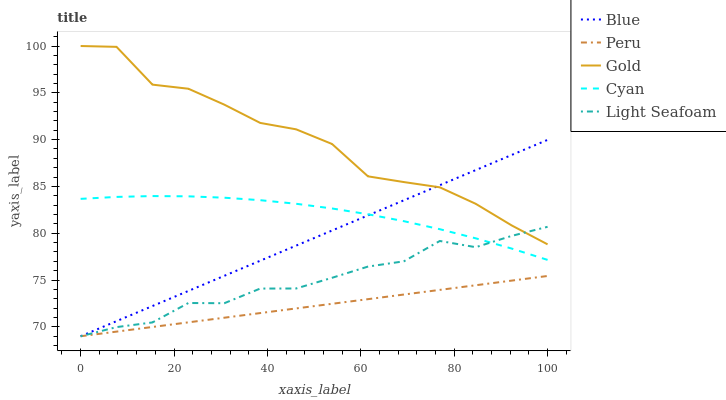Does Peru have the minimum area under the curve?
Answer yes or no. Yes. Does Gold have the maximum area under the curve?
Answer yes or no. Yes. Does Cyan have the minimum area under the curve?
Answer yes or no. No. Does Cyan have the maximum area under the curve?
Answer yes or no. No. Is Blue the smoothest?
Answer yes or no. Yes. Is Gold the roughest?
Answer yes or no. Yes. Is Cyan the smoothest?
Answer yes or no. No. Is Cyan the roughest?
Answer yes or no. No. Does Cyan have the lowest value?
Answer yes or no. No. Does Cyan have the highest value?
Answer yes or no. No. Is Peru less than Cyan?
Answer yes or no. Yes. Is Gold greater than Cyan?
Answer yes or no. Yes. Does Peru intersect Cyan?
Answer yes or no. No. 